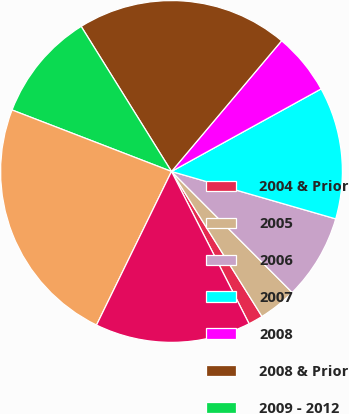Convert chart. <chart><loc_0><loc_0><loc_500><loc_500><pie_chart><fcel>2004 & Prior<fcel>2005<fcel>2006<fcel>2007<fcel>2008<fcel>2008 & Prior<fcel>2009 - 2012<fcel>Total<fcel>FNMA FHLMC and GNMA<nl><fcel>1.38%<fcel>3.6%<fcel>8.05%<fcel>12.5%<fcel>5.83%<fcel>20.01%<fcel>10.28%<fcel>23.63%<fcel>14.73%<nl></chart> 